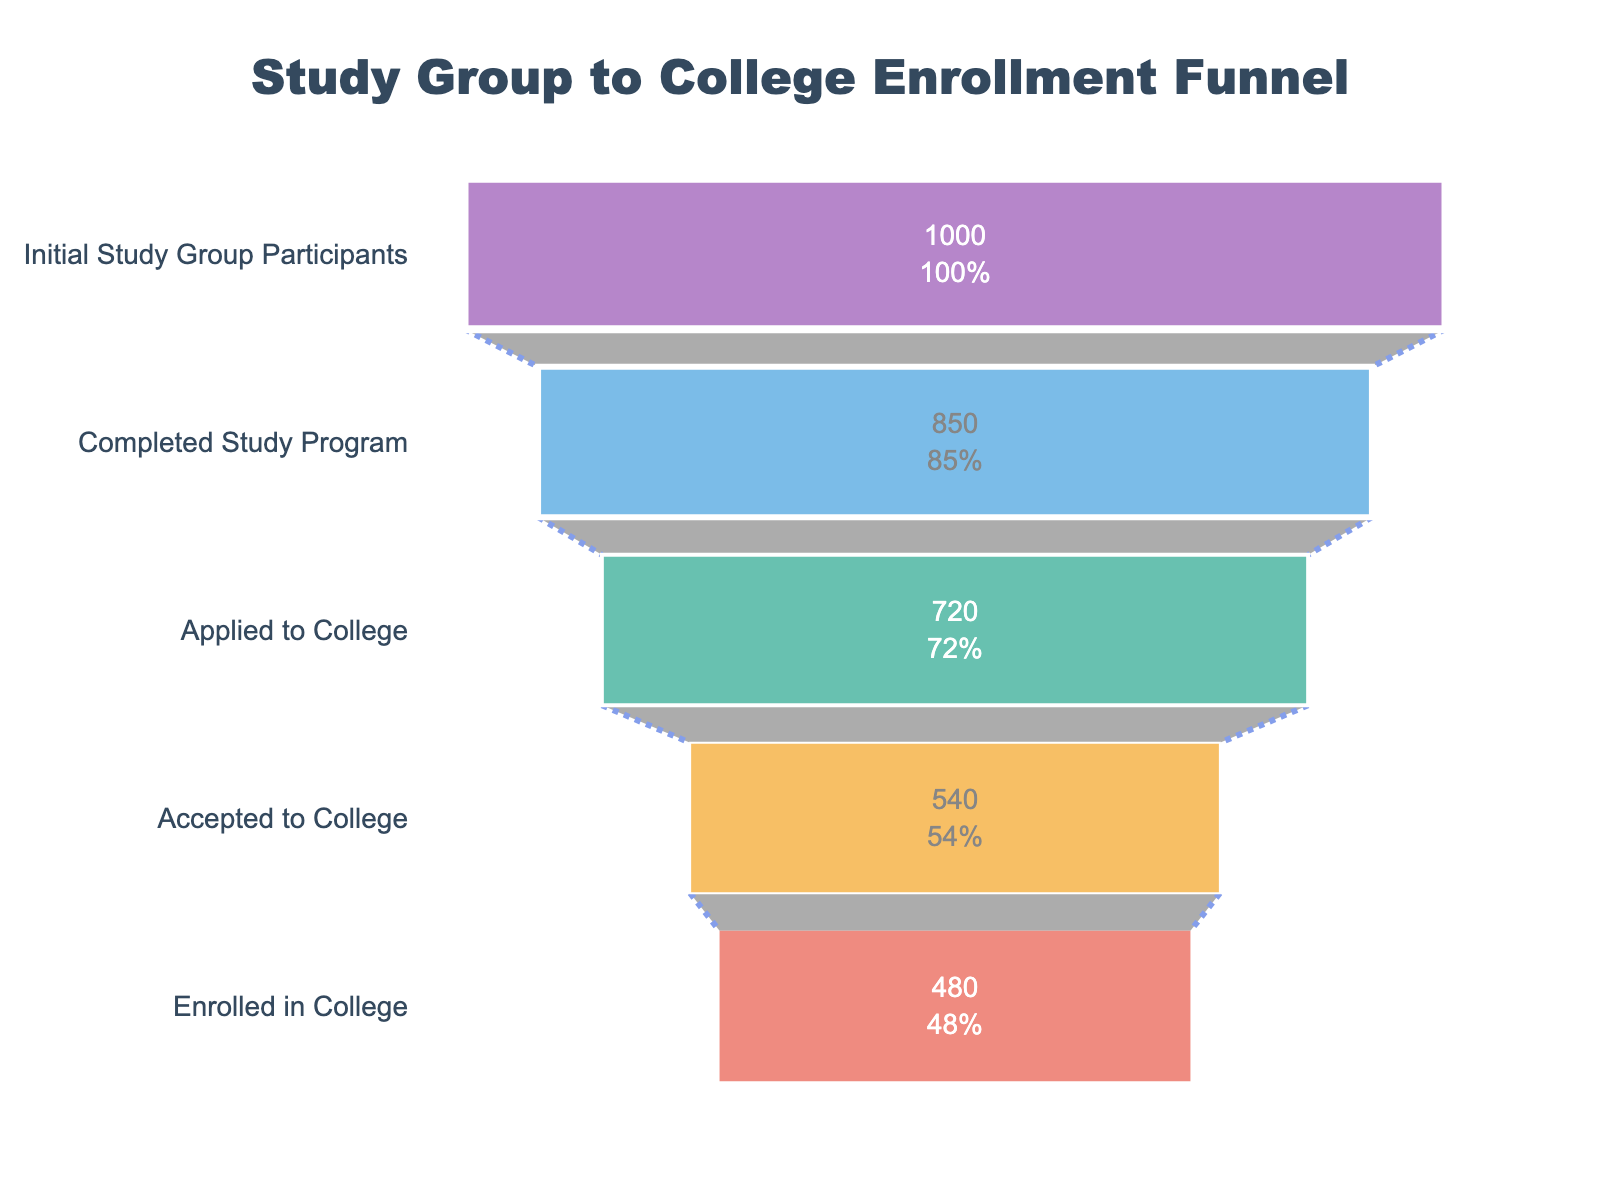How many stages are in the funnel chart? The funnel chart shows stages by the number of horizontal bars representing each phase of the study group's journey to college enrollment. By counting these stages, we can identify their total number.
Answer: 5 What's the percentage difference between participants who completed the study program and those who applied to college? First, identify the percentages: 85% completed the study program, and 72% applied to college. Then, find the difference between them: 85% - 72% = 13%.
Answer: 13% What's the total number of participants who did not enroll in college after completing the study program? Begin with the number of participants who completed the study program (850). Subtract the number who enrolled in college (480) to find how many did not: 850 - 480 = 370.
Answer: 370 Which stage had the greatest drop in participant numbers compared to the previous stage? Review the participant numbers for each stage and calculate the difference between consecutive stages. The largest drop is between the "Completed Study Program" (850) and "Applied to College" (720), which is a difference of 130 participants.
Answer: Completed Study Program to Applied to College What is the ratio of participants who were accepted to college to those who completed the study program? Identify the number of participants accepted to college (540) and those who completed the study program (850). Divide them to find the ratio: 540 / 850. Simplifying this fraction gives roughly 0.635.
Answer: 0.635 How many participants were lost between the stages 'Applied to College' and 'Accepted to College'? Check the participant numbers for these two stages: 720 applied to college, and 540 were accepted. Subtract the accepted from the applied: 720 - 540 = 180.
Answer: 180 What percentage of initial participants ended up enrolling in college? Identify the number of participants initially (1000) and those who enrolled in college (480). Divide the enrolled by the initial participants and multiply by 100: (480 / 1000) * 100 = 48%.
Answer: 48% How does the number of participants who applied to college compare to those who completed the study program? Compare the numbers of the two stages: 720 participants applied to college, whereas 850 completed the study program. Since 720 is less than 850, the number of applicants to college is lower.
Answer: Less If 20 more participants had enrolled in college, what would have been the new percentage of college enrollment? Start by calculating the new total of enrolled participants: 480 + 20 = 500. Then find the new percentage: (500 / 1000) * 100 = 50%.
Answer: 50% 